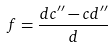<formula> <loc_0><loc_0><loc_500><loc_500>f = \frac { d c ^ { \prime \prime } - c d ^ { \prime \prime } } { d }</formula> 